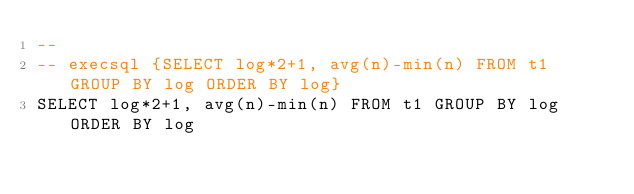<code> <loc_0><loc_0><loc_500><loc_500><_SQL_>-- 
-- execsql {SELECT log*2+1, avg(n)-min(n) FROM t1 GROUP BY log ORDER BY log}
SELECT log*2+1, avg(n)-min(n) FROM t1 GROUP BY log ORDER BY log</code> 